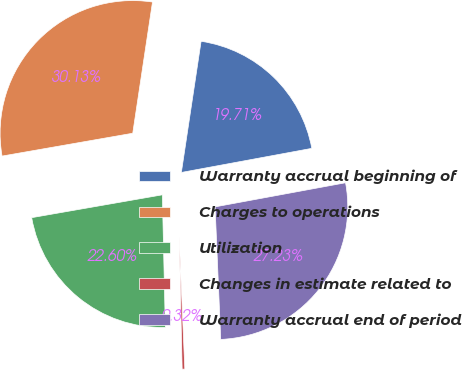<chart> <loc_0><loc_0><loc_500><loc_500><pie_chart><fcel>Warranty accrual beginning of<fcel>Charges to operations<fcel>Utilization<fcel>Changes in estimate related to<fcel>Warranty accrual end of period<nl><fcel>19.71%<fcel>30.13%<fcel>22.6%<fcel>0.32%<fcel>27.23%<nl></chart> 